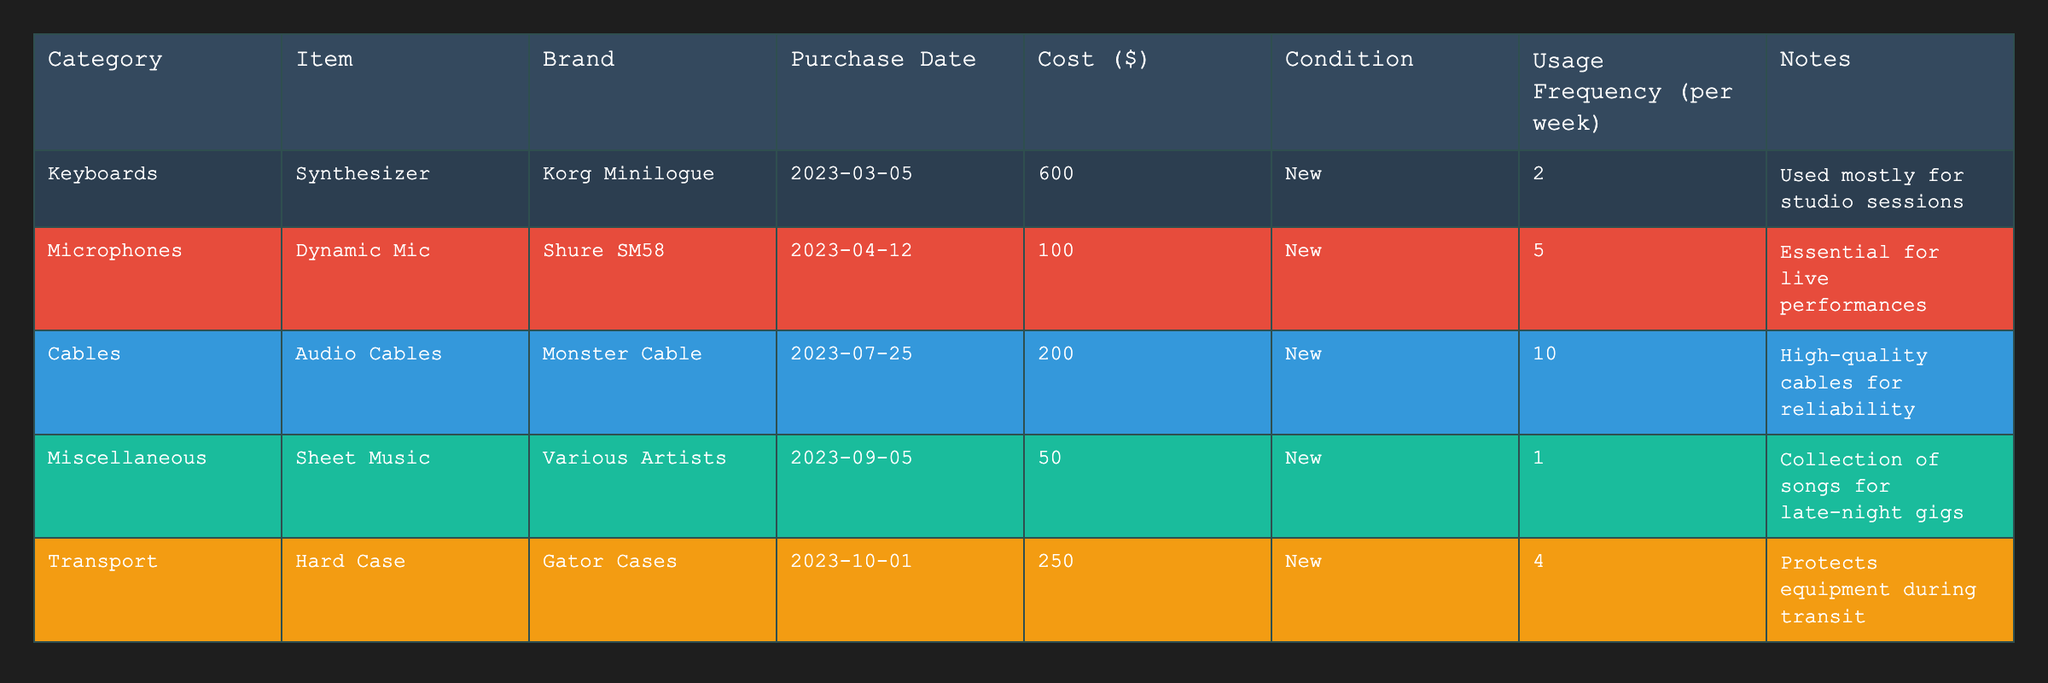What is the total cost of all equipment and instruments combined? To find the total cost, we need to sum the costs of all items listed in the table: 600 + 100 + 200 + 50 + 250 = 1200.
Answer: 1200 Which item has the highest cost? By comparing the cost values in the table, the Synthesizer (Korg Minilogue) has the highest cost at $600.
Answer: Korg Minilogue How many items are listed under the 'Microphones' category? There is only one item listed under the 'Microphones' category, which is the Dynamic Mic (Shure SM58).
Answer: 1 What is the average cost of the items in the table? To find the average, we sum the costs (600 + 100 + 200 + 50 + 250 = 1200) and divide by the number of items (5), which gives us 1200 / 5 = 240.
Answer: 240 Is the transport equipment used more frequently than the synthesizer? The Transport (Hard Case) has a usage frequency of 4 per week, while the Synthesizer has a usage frequency of 2 per week, so it is true that the transport equipment is used more frequently.
Answer: Yes Which brand of microphone is listed in the table? According to the table, the brand of the listed microphone is Shure.
Answer: Shure How much is spent on cables in total? The total spent on cables, specifically Audio Cables from Monster Cable, is recorded as $200 in the table.
Answer: 200 If the equipment is used for a total of 56 weeks in a year, what would be the total usage frequency for the Dynamic Mic? The usage frequency for the Dynamic Mic is 5 per week; therefore, over 56 weeks, the total usage frequency would be calculated as 5 * 56 = 280.
Answer: 280 Is the sheet music a new item? The table indicates that the sheet music categorized under 'Miscellaneous' is indeed stated as new.
Answer: Yes Which category has the lowest total cost? The 'Miscellaneous' category, which includes only the Sheet Music costing $50, has the lowest total cost compared to others.
Answer: Miscellaneous 